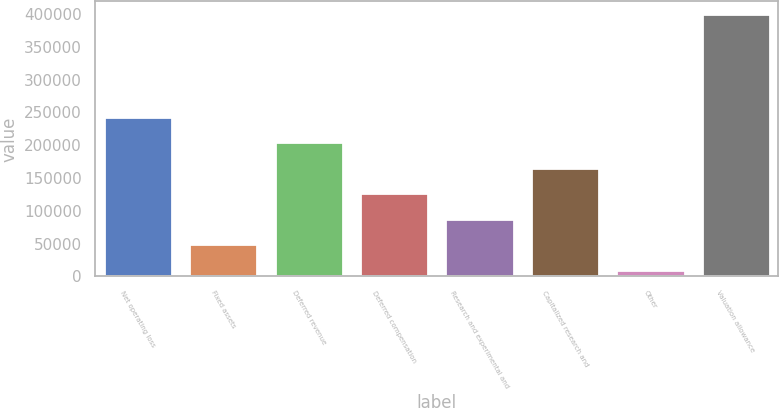Convert chart. <chart><loc_0><loc_0><loc_500><loc_500><bar_chart><fcel>Net operating loss<fcel>Fixed assets<fcel>Deferred revenue<fcel>Deferred compensation<fcel>Research and experimental and<fcel>Capitalized research and<fcel>Other<fcel>Valuation allowance<nl><fcel>243652<fcel>49060.4<fcel>204734<fcel>126897<fcel>87978.8<fcel>165816<fcel>10142<fcel>399326<nl></chart> 